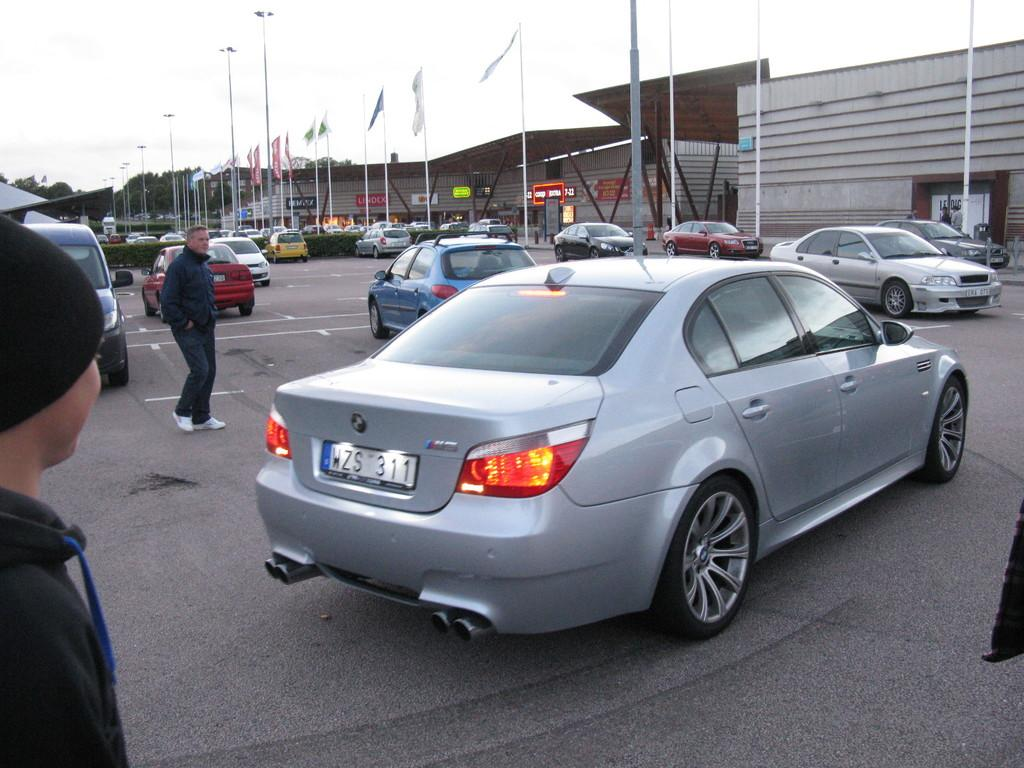Provide a one-sentence caption for the provided image. a silver car in a parking lot with license plate WZS 311. 